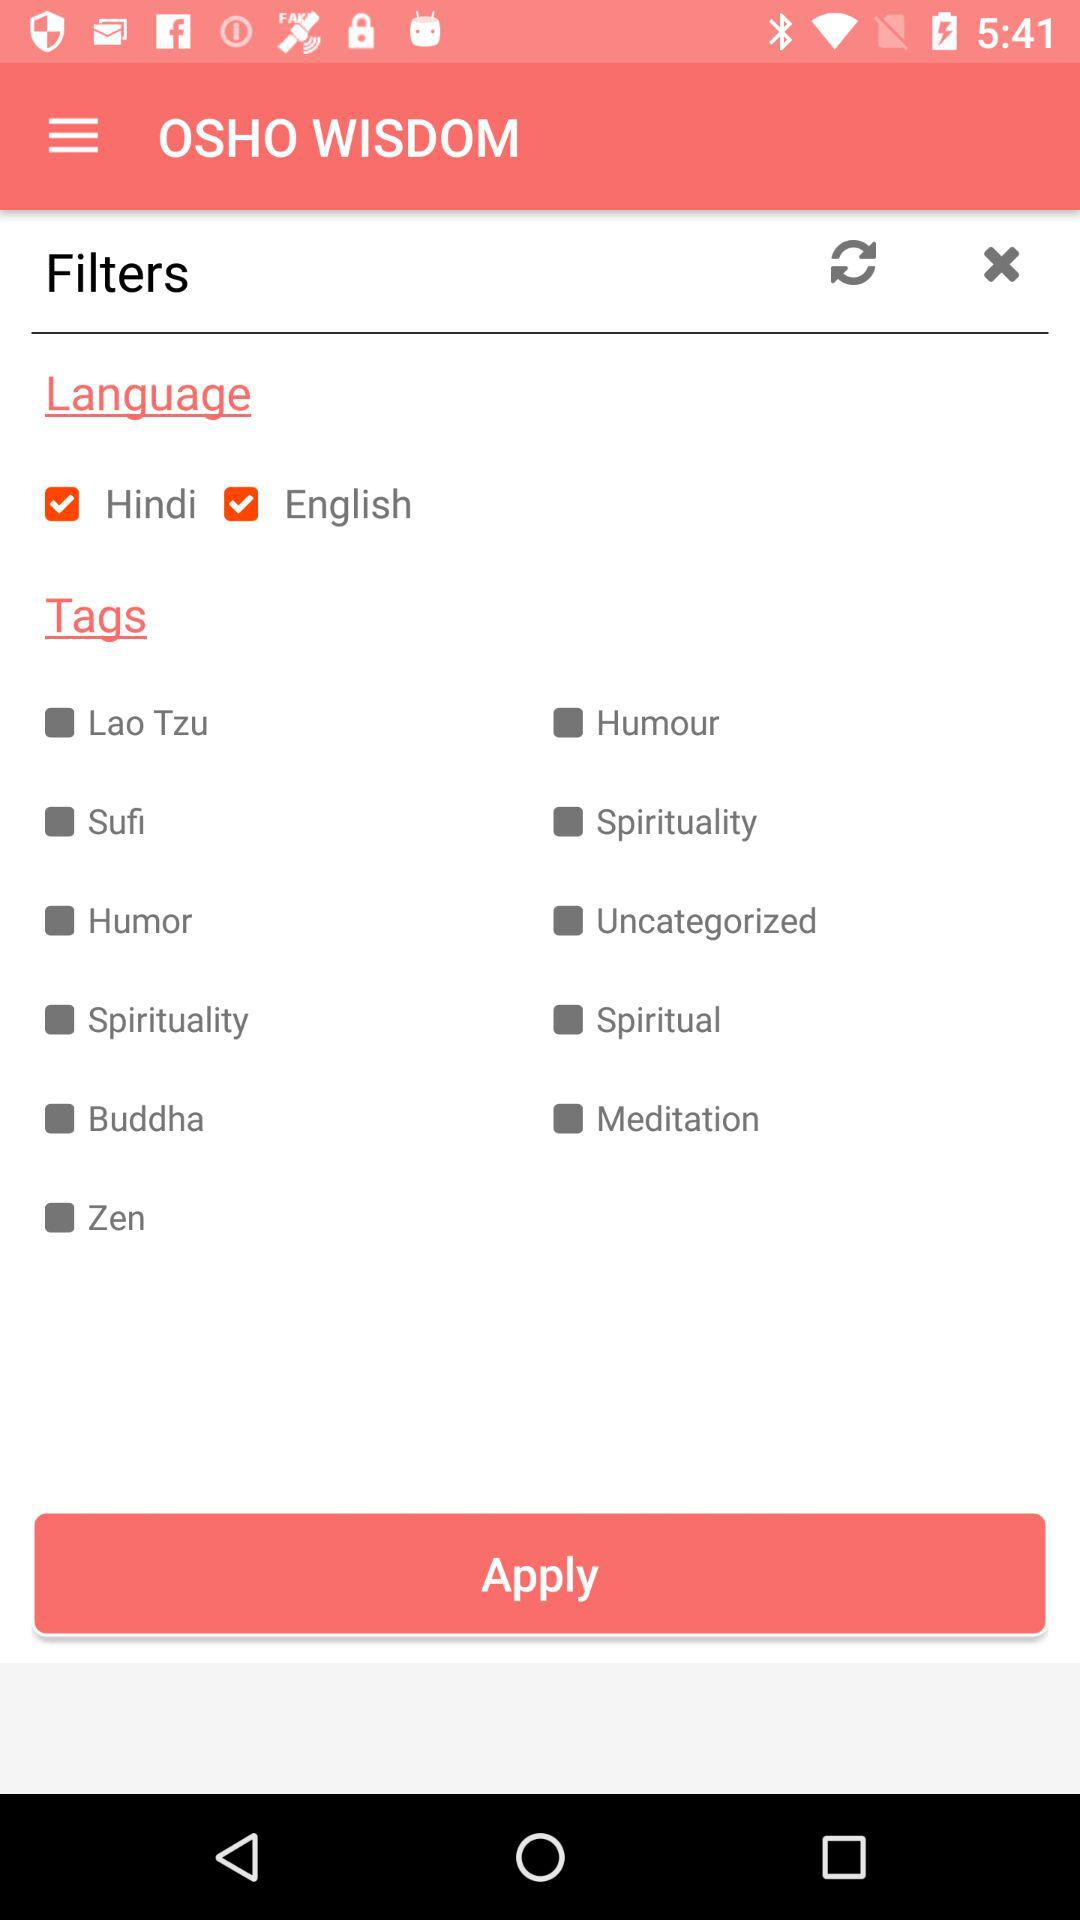What is the application's version?
When the provided information is insufficient, respond with <no answer>. <no answer> 